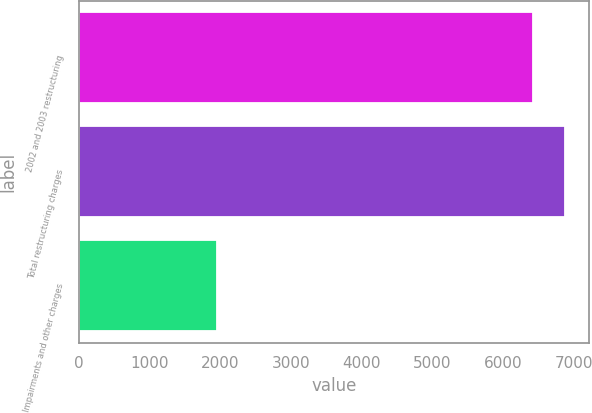Convert chart to OTSL. <chart><loc_0><loc_0><loc_500><loc_500><bar_chart><fcel>2002 and 2003 restructuring<fcel>Total restructuring charges<fcel>Impairments and other charges<nl><fcel>6420<fcel>6867.1<fcel>1949<nl></chart> 